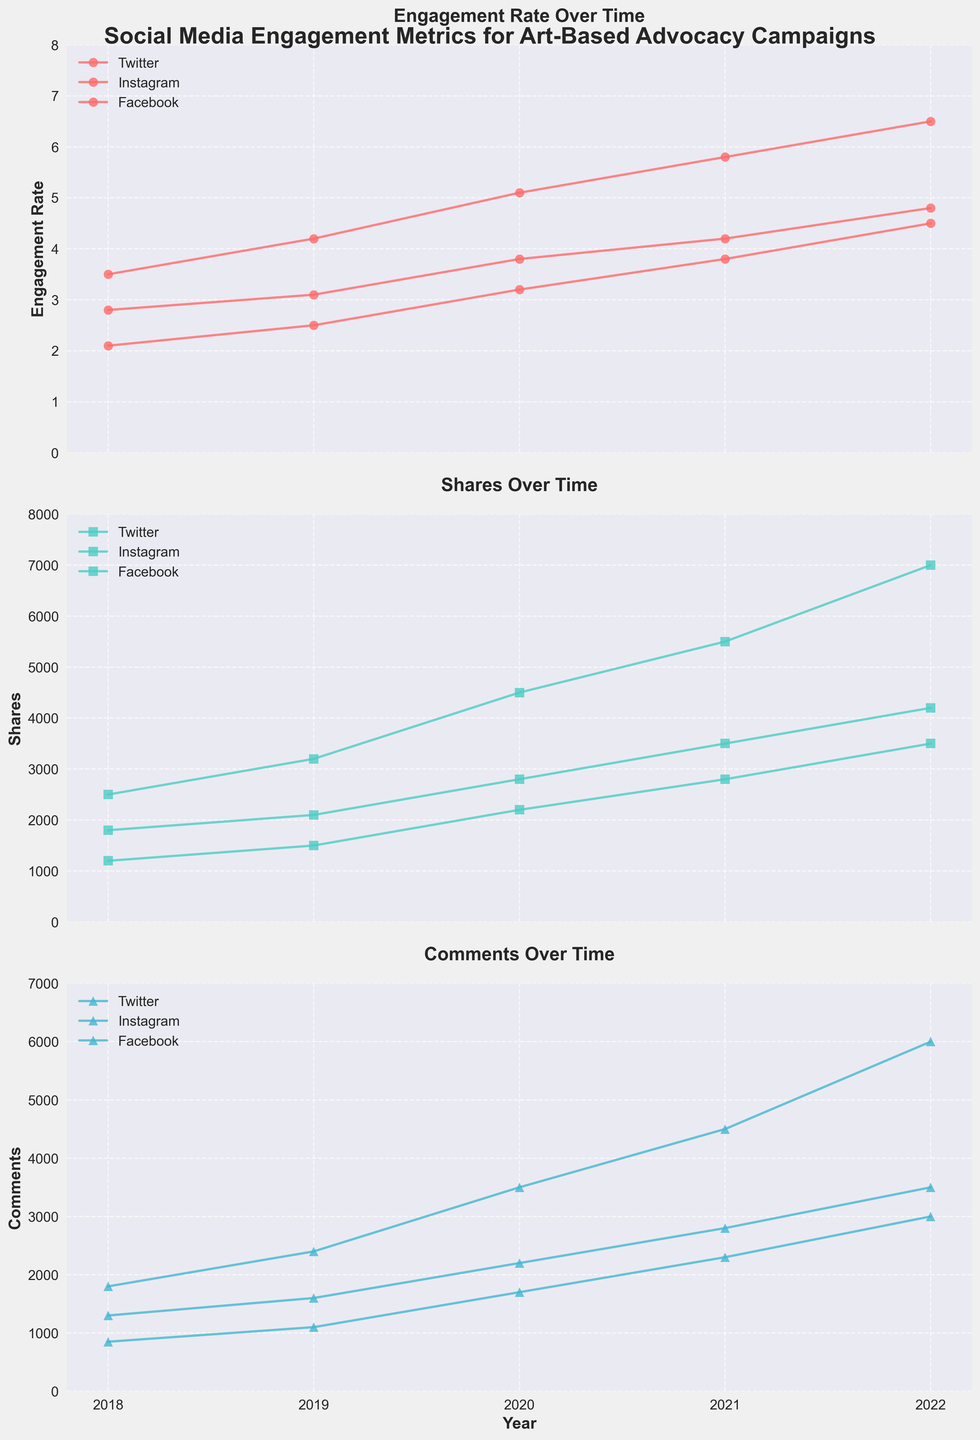What's the title of the entire figure? The title of the plot is shown prominently at the top of the figure.
Answer: Social Media Engagement Metrics for Art-Based Advocacy Campaigns Which platform had the highest engagement rate in 2022? By examining the last data point in the 'Engagement Rate Over Time' plot for 2022, we can see that Instagram had the highest engagement rate.
Answer: Instagram How does the 'Shares' metric for Twitter in 2020 compare to Facebook in the same year? In the 'Shares Over Time' plot, we see the data point for Twitter in 2020 is 2200 shares, while Facebook has 2800 shares. Facebook had more shares.
Answer: Facebook had more shares Which year saw the highest engagement rate on Instagram? By looking at the 'Engagement Rate Over Time' plot, we can see that in 2022, Instagram had the highest engagement rate at 6.5.
Answer: 2022 What is the average number of comments on Facebook across all years? Add up the number of comments on Facebook for each year and divide by the number of years: (1300 + 1600 + 2200 + 2800 + 3500)/5 = 11400/5 = 2280
Answer: 2280 Between 2019 and 2021, which platform had the greatest increase in engagement rate? Calculate the difference between 2019 and 2021 for each platform: Twitter had an increase from 2.5 to 3.8 (1.3), Instagram from 4.2 to 5.8 (1.6), and Facebook from 3.1 to 4.2 (1.1). Instagram had the greatest increase.
Answer: Instagram Looking at the 'Comments Over Time' plot, which campaign had consistently increasing comments on Facebook? For Facebook, #ArtisticRedemption is the campaign with increasing comments every year: 1300 (2018), 1600 (2019), 2200 (2020), 2800 (2021), 3500 (2022).
Answer: #ArtisticRedemption What is the highest number of shares recorded across all platforms in a single year? From the 'Shares Over Time' plot, the highest value is on Instagram in 2022 with 7000 shares.
Answer: 7000 Which campaign had the lowest engagement rate on Twitter? In the 'Engagement Rate Over Time' plot, #ArtForJustice in 2018 had the lowest engagement rate on Twitter with 2.1.
Answer: #ArtForJustice Comparing all platforms, which year had the lowest engagement rates across all platforms? From the 'Engagement Rate Over Time' plot, 2018 had the lowest engagement rates for all platforms: Twitter (2.1), Instagram (3.5), Facebook (2.8).
Answer: 2018 